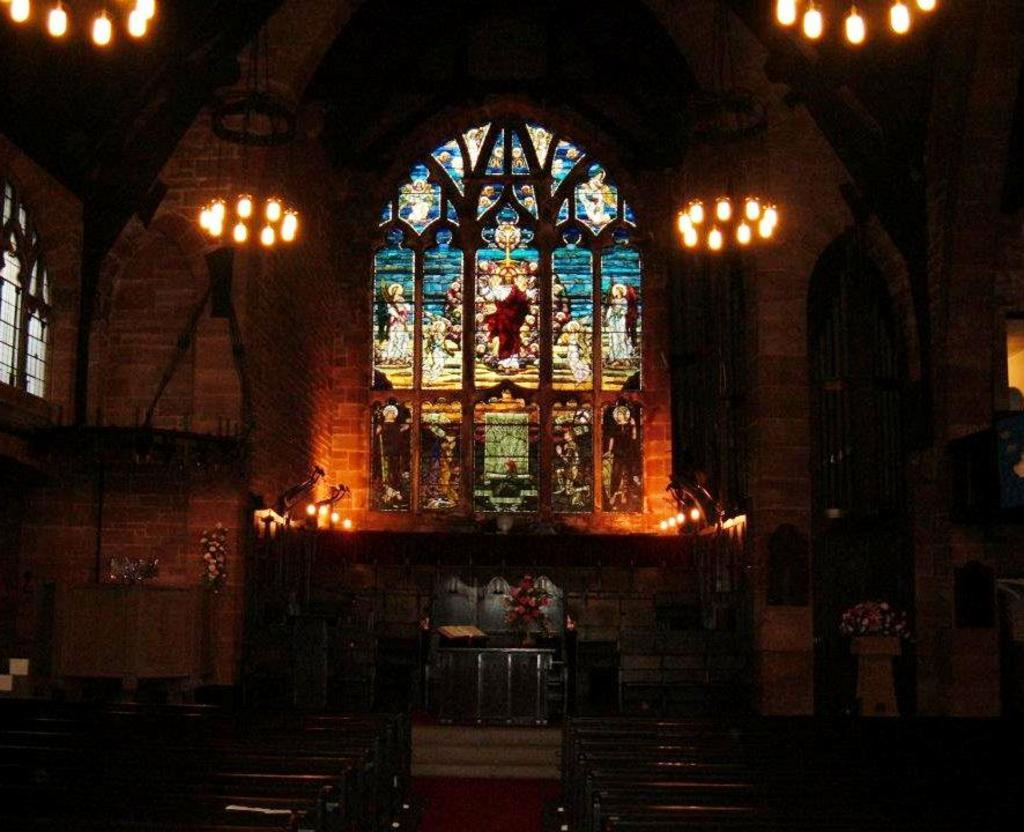What type of building is shown in the image? The image is an inside view of a church. What can be seen near the altar or in the front of the church? There are candles in the image. Are there any other objects or items visible in the church? Yes, there are other objects in the image. What is one architectural feature that can be seen in the church? There is a window in the image. What type of lighting is present in the church? There are lights in the image. How would you describe the overall lighting in the image? The image appears to be slightly dark. What type of crown is being worn by the teacher in the image? There is no teacher or crown present in the image; it is an inside view of a church. 